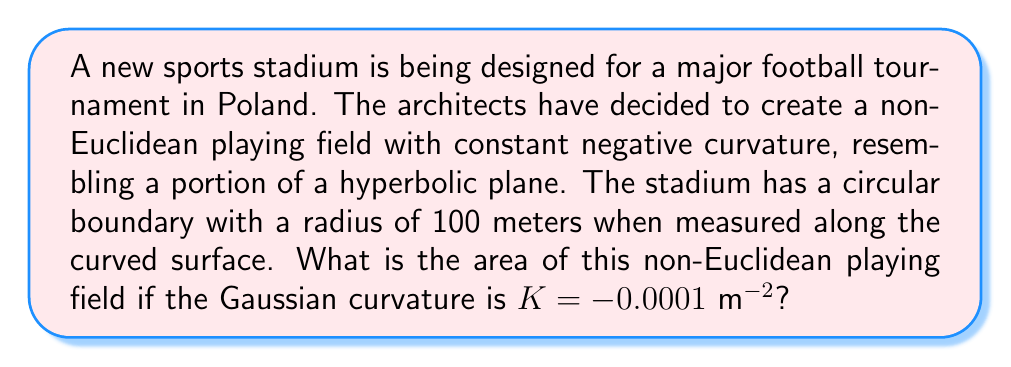Provide a solution to this math problem. To solve this problem, we'll use the formula for the area of a circle in hyperbolic geometry:

1) The area of a circle in a hyperbolic plane is given by:

   $$A = \frac{4\pi}{|K|} \sinh^2\left(\frac{\sqrt{|K|}R}{2}\right)$$

   Where $K$ is the Gaussian curvature and $R$ is the radius.

2) We're given:
   $K = -0.0001 \text{ m}^{-2}$
   $R = 100 \text{ m}$

3) Let's substitute these values:

   $$A = \frac{4\pi}{|-0.0001|} \sinh^2\left(\frac{\sqrt{|-0.0001|}100}{2}\right)$$

4) Simplify:

   $$A = 40000\pi \sinh^2(0.05\sqrt{10})$$

5) Calculate:
   
   $0.05\sqrt{10} \approx 0.158114$
   
   $\sinh(0.158114) \approx 0.158747$
   
   $0.158747^2 \approx 0.025201$

6) Final calculation:

   $$A \approx 40000\pi \cdot 0.025201 \approx 3167.57 \text{ m}^2$$
Answer: $3167.57 \text{ m}^2$ 